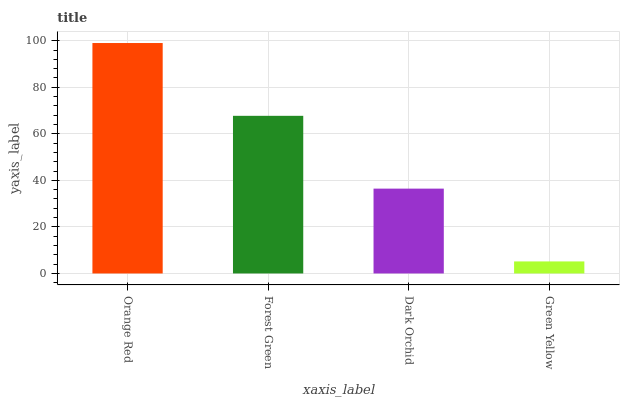Is Green Yellow the minimum?
Answer yes or no. Yes. Is Orange Red the maximum?
Answer yes or no. Yes. Is Forest Green the minimum?
Answer yes or no. No. Is Forest Green the maximum?
Answer yes or no. No. Is Orange Red greater than Forest Green?
Answer yes or no. Yes. Is Forest Green less than Orange Red?
Answer yes or no. Yes. Is Forest Green greater than Orange Red?
Answer yes or no. No. Is Orange Red less than Forest Green?
Answer yes or no. No. Is Forest Green the high median?
Answer yes or no. Yes. Is Dark Orchid the low median?
Answer yes or no. Yes. Is Orange Red the high median?
Answer yes or no. No. Is Orange Red the low median?
Answer yes or no. No. 